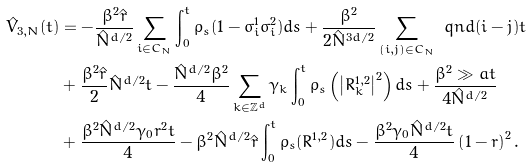Convert formula to latex. <formula><loc_0><loc_0><loc_500><loc_500>\hat { V } _ { 3 , N } ( t ) & = - \frac { \beta ^ { 2 } \hat { r } } { \hat { N } ^ { d \slash 2 } } \sum _ { i \in C _ { N } } \int _ { 0 } ^ { t } \rho _ { s } ( 1 - \sigma _ { i } ^ { 1 } \sigma _ { i } ^ { 2 } ) d s + \frac { \beta ^ { 2 } } { 2 \hat { N } ^ { 3 d \slash 2 } } \sum _ { ( i , j ) \in C _ { N } } \ q n d ( i - j ) t \\ & + \frac { \beta ^ { 2 } \hat { r } } { 2 } \hat { N } ^ { d \slash 2 } t - \frac { \hat { N } ^ { d \slash 2 } \beta ^ { 2 } } { 4 } \sum _ { k \in \mathbb { Z } ^ { d } } \gamma _ { k } \int _ { 0 } ^ { t } \rho _ { s } \left ( \left | R _ { k } ^ { 1 , 2 } \right | ^ { 2 } \right ) d s + \frac { \beta ^ { 2 } \gg a t } { 4 \hat { N } ^ { d \slash 2 } } \\ & + \frac { \beta ^ { 2 } \hat { N } ^ { d \slash 2 } \gamma _ { 0 } r ^ { 2 } t } { 4 } - \beta ^ { 2 } \hat { N } ^ { d \slash 2 } \hat { r } \int _ { 0 } ^ { t } \rho _ { s } ( R ^ { 1 , 2 } ) d s - \frac { \beta ^ { 2 } \gamma _ { 0 } \hat { N } ^ { d \slash 2 } t } { 4 } \left ( 1 - r \right ) ^ { 2 } .</formula> 